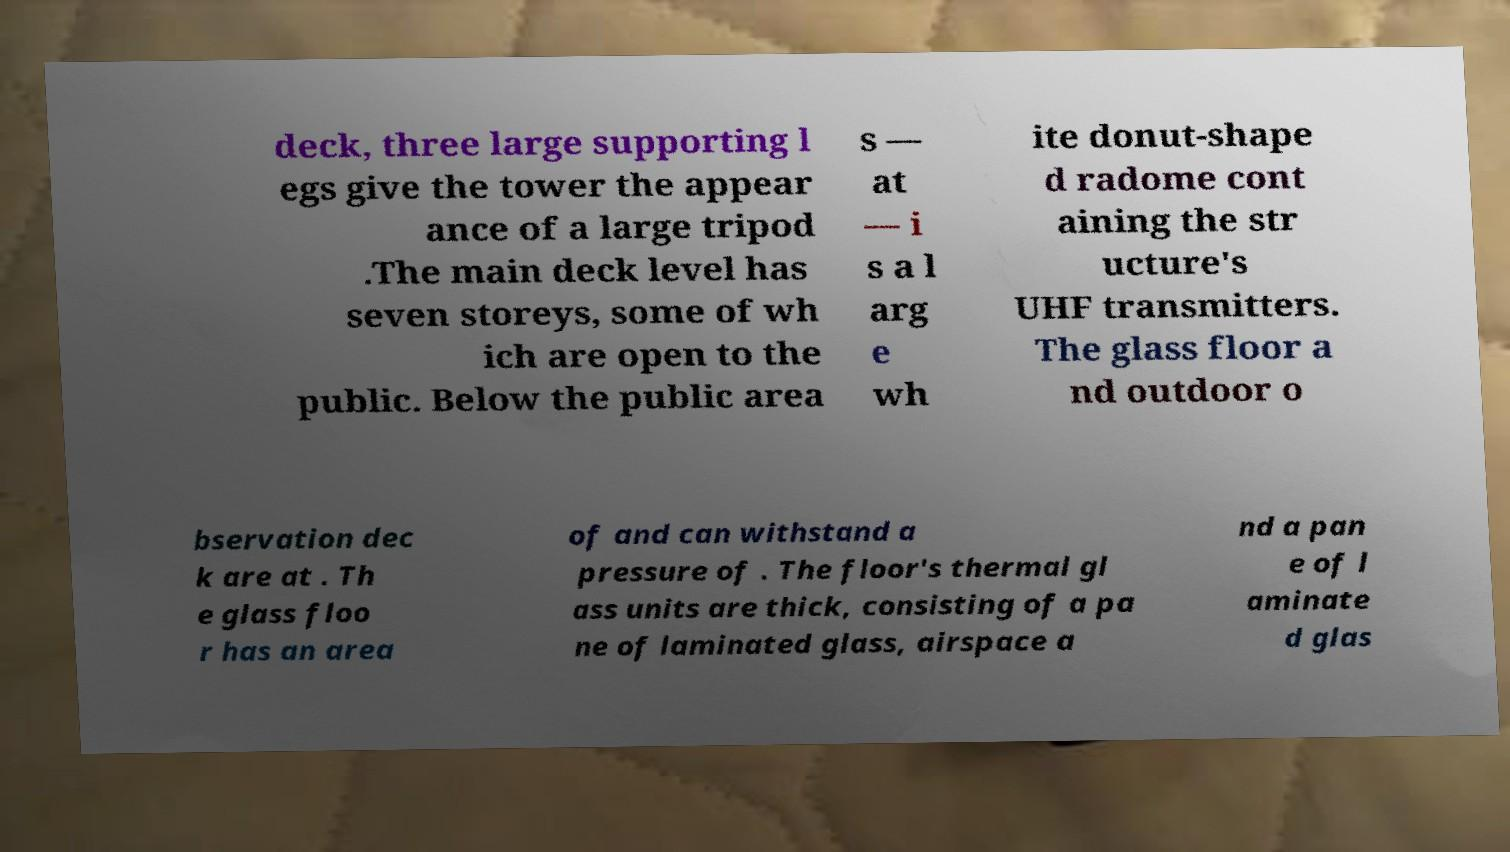Please read and relay the text visible in this image. What does it say? deck, three large supporting l egs give the tower the appear ance of a large tripod .The main deck level has seven storeys, some of wh ich are open to the public. Below the public area s — at — i s a l arg e wh ite donut-shape d radome cont aining the str ucture's UHF transmitters. The glass floor a nd outdoor o bservation dec k are at . Th e glass floo r has an area of and can withstand a pressure of . The floor's thermal gl ass units are thick, consisting of a pa ne of laminated glass, airspace a nd a pan e of l aminate d glas 